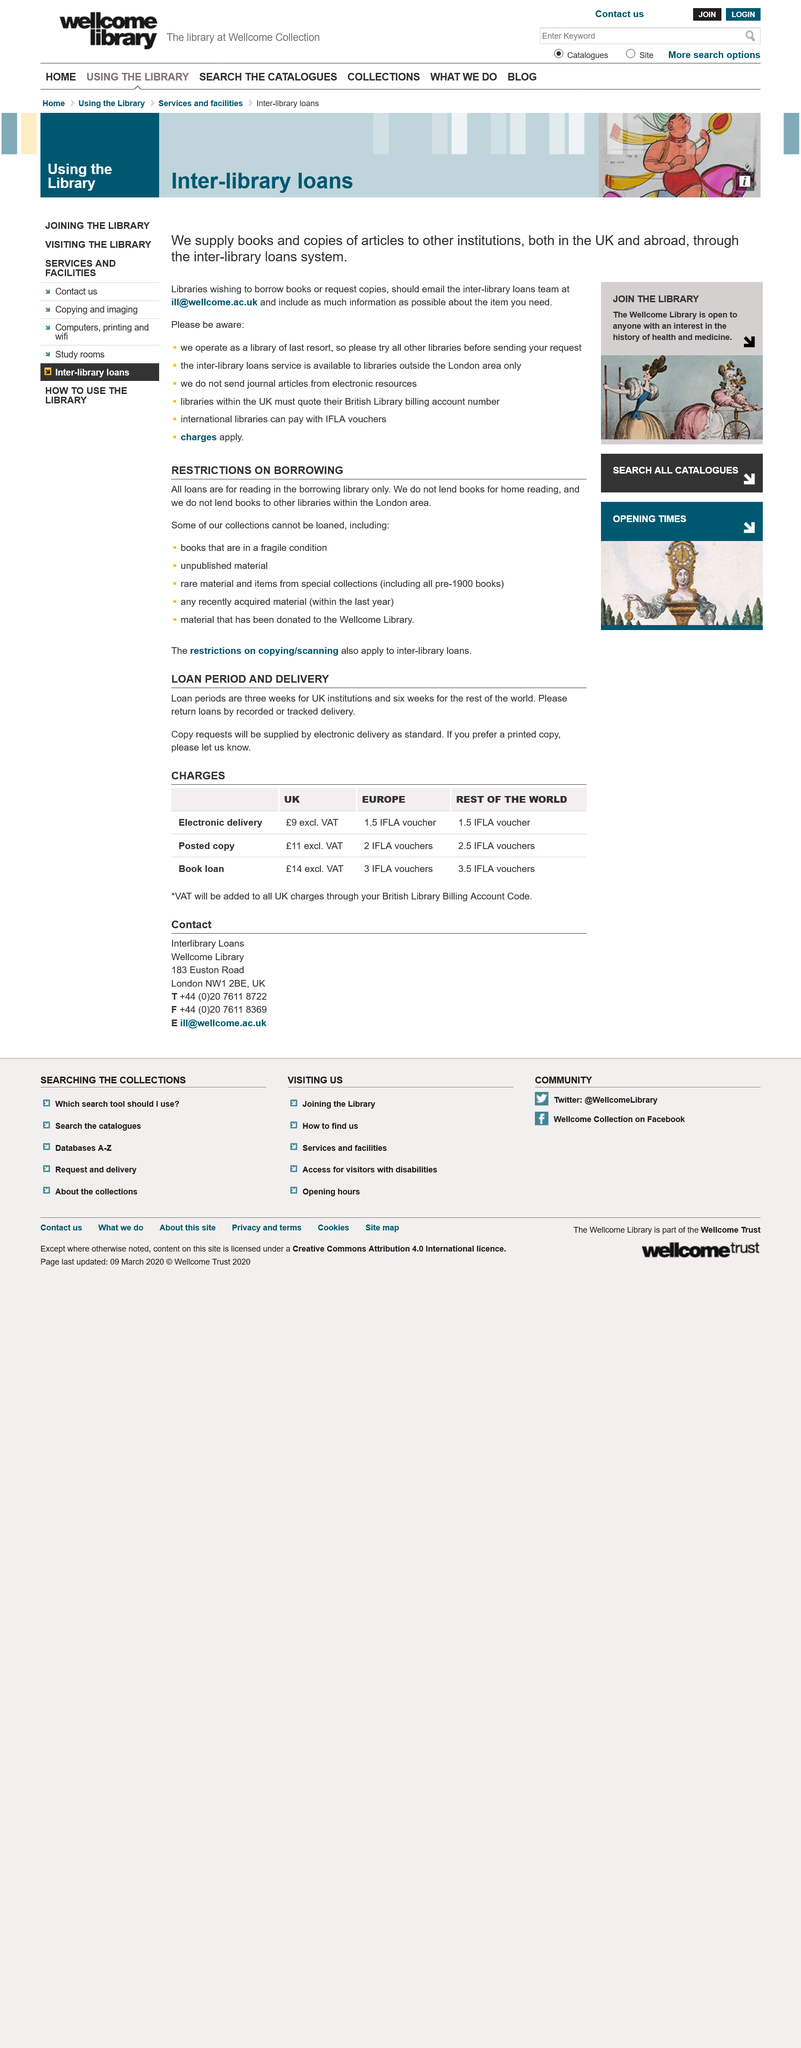List a handful of essential elements in this visual. The loan period for UK institutions is three weeks and six weeks for the rest of the world, which is different from the loan period for institutions located anywhere in the world, which is not specified. The loan period for UK institutions is the length of time that materials borrowed from an institution may be kept before they must be returned. It is the standard delivery method for copy requests that electronic delivery is used. 